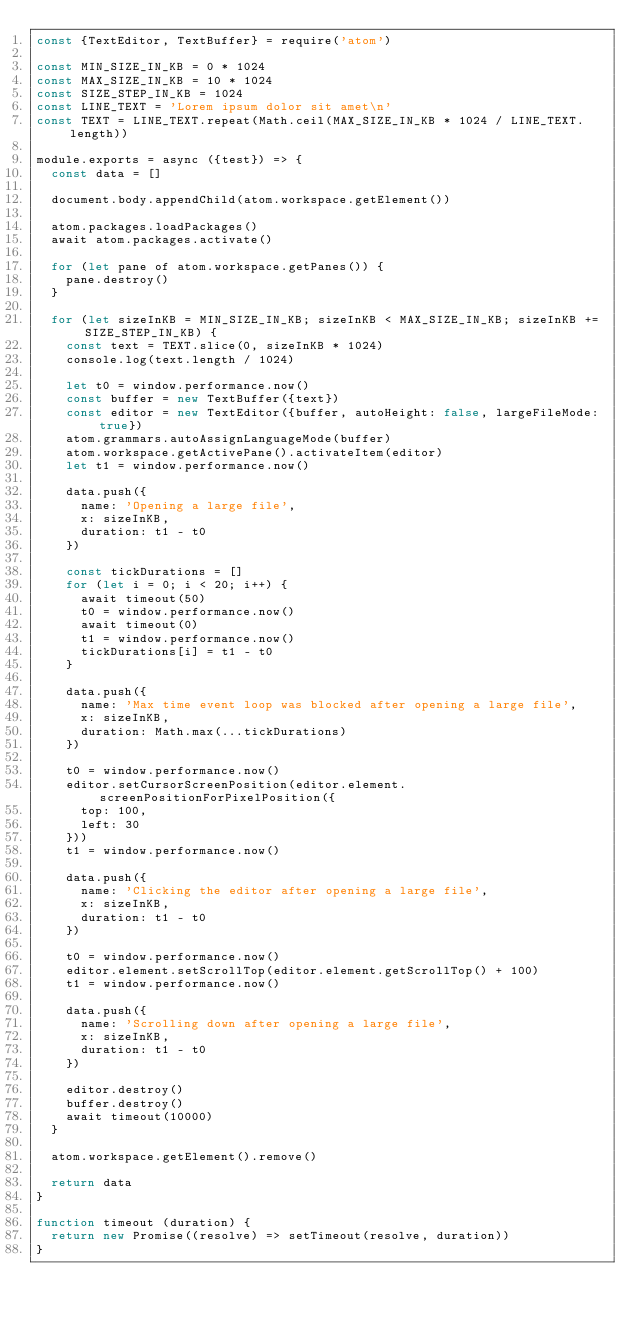Convert code to text. <code><loc_0><loc_0><loc_500><loc_500><_JavaScript_>const {TextEditor, TextBuffer} = require('atom')

const MIN_SIZE_IN_KB = 0 * 1024
const MAX_SIZE_IN_KB = 10 * 1024
const SIZE_STEP_IN_KB = 1024
const LINE_TEXT = 'Lorem ipsum dolor sit amet\n'
const TEXT = LINE_TEXT.repeat(Math.ceil(MAX_SIZE_IN_KB * 1024 / LINE_TEXT.length))

module.exports = async ({test}) => {
  const data = []

  document.body.appendChild(atom.workspace.getElement())

  atom.packages.loadPackages()
  await atom.packages.activate()

  for (let pane of atom.workspace.getPanes()) {
    pane.destroy()
  }

  for (let sizeInKB = MIN_SIZE_IN_KB; sizeInKB < MAX_SIZE_IN_KB; sizeInKB += SIZE_STEP_IN_KB) {
    const text = TEXT.slice(0, sizeInKB * 1024)
    console.log(text.length / 1024)

    let t0 = window.performance.now()
    const buffer = new TextBuffer({text})
    const editor = new TextEditor({buffer, autoHeight: false, largeFileMode: true})
    atom.grammars.autoAssignLanguageMode(buffer)
    atom.workspace.getActivePane().activateItem(editor)
    let t1 = window.performance.now()

    data.push({
      name: 'Opening a large file',
      x: sizeInKB,
      duration: t1 - t0
    })

    const tickDurations = []
    for (let i = 0; i < 20; i++) {
      await timeout(50)
      t0 = window.performance.now()
      await timeout(0)
      t1 = window.performance.now()
      tickDurations[i] = t1 - t0
    }

    data.push({
      name: 'Max time event loop was blocked after opening a large file',
      x: sizeInKB,
      duration: Math.max(...tickDurations)
    })

    t0 = window.performance.now()
    editor.setCursorScreenPosition(editor.element.screenPositionForPixelPosition({
      top: 100,
      left: 30
    }))
    t1 = window.performance.now()

    data.push({
      name: 'Clicking the editor after opening a large file',
      x: sizeInKB,
      duration: t1 - t0
    })

    t0 = window.performance.now()
    editor.element.setScrollTop(editor.element.getScrollTop() + 100)
    t1 = window.performance.now()

    data.push({
      name: 'Scrolling down after opening a large file',
      x: sizeInKB,
      duration: t1 - t0
    })

    editor.destroy()
    buffer.destroy()
    await timeout(10000)
  }

  atom.workspace.getElement().remove()

  return data
}

function timeout (duration) {
  return new Promise((resolve) => setTimeout(resolve, duration))
}
</code> 